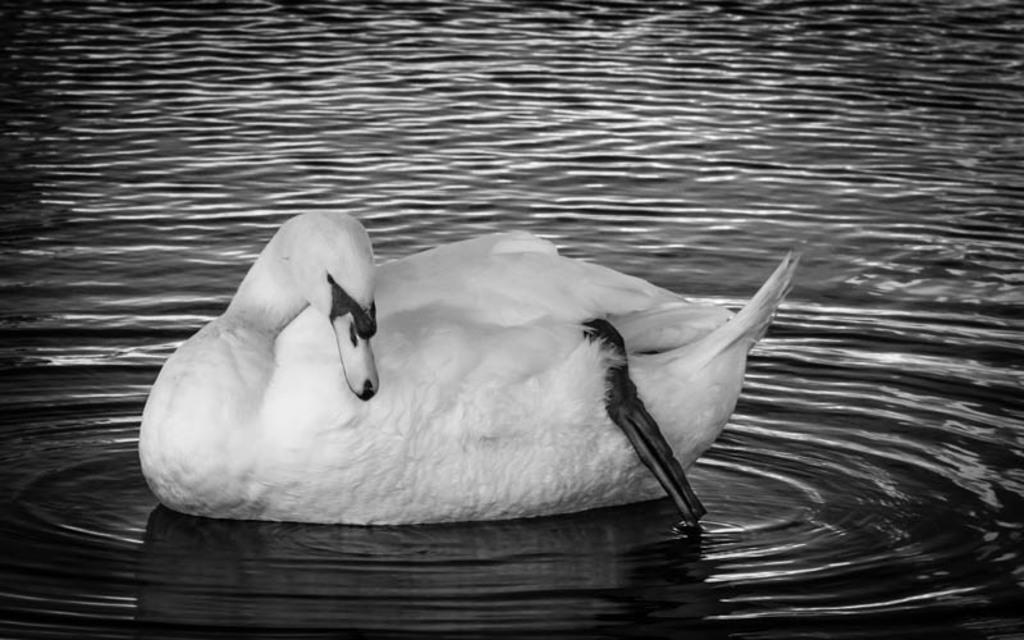What type of animal can be seen in the water in the image? There is a swan in the water in the image. What type of building can be seen in the image? There is no building present in the image; it features a swan in the water. Is the water in the image hot? The image does not provide any information about the temperature of the water. 